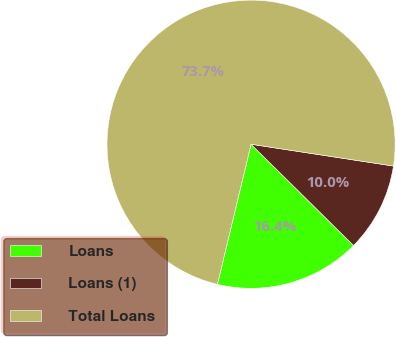<chart> <loc_0><loc_0><loc_500><loc_500><pie_chart><fcel>Loans<fcel>Loans (1)<fcel>Total Loans<nl><fcel>16.35%<fcel>9.98%<fcel>73.66%<nl></chart> 